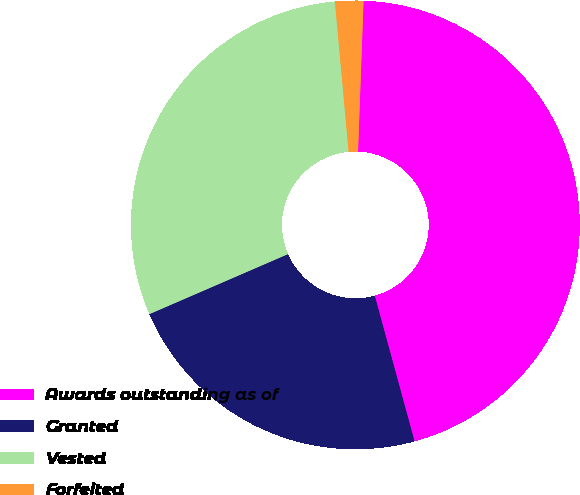<chart> <loc_0><loc_0><loc_500><loc_500><pie_chart><fcel>Awards outstanding as of<fcel>Granted<fcel>Vested<fcel>Forfeited<nl><fcel>45.17%<fcel>22.74%<fcel>30.05%<fcel>2.03%<nl></chart> 